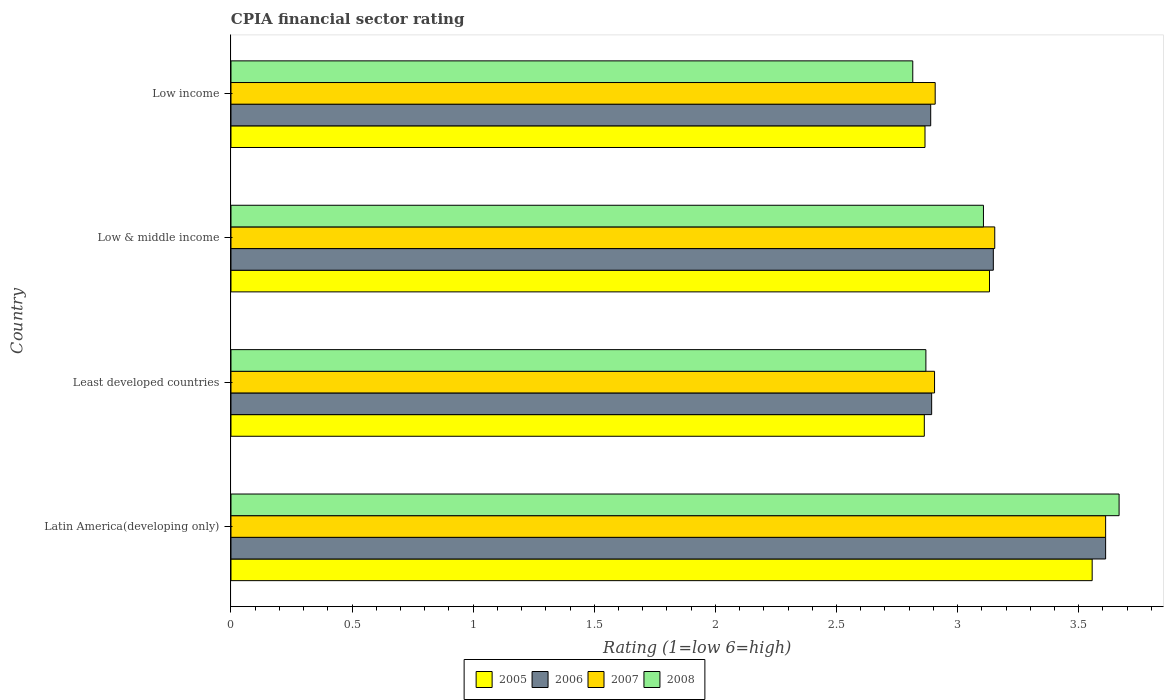How many different coloured bars are there?
Offer a terse response. 4. How many groups of bars are there?
Keep it short and to the point. 4. Are the number of bars on each tick of the Y-axis equal?
Provide a short and direct response. Yes. What is the label of the 1st group of bars from the top?
Your answer should be very brief. Low income. In how many cases, is the number of bars for a given country not equal to the number of legend labels?
Your answer should be compact. 0. What is the CPIA rating in 2008 in Low income?
Offer a very short reply. 2.81. Across all countries, what is the maximum CPIA rating in 2007?
Offer a terse response. 3.61. Across all countries, what is the minimum CPIA rating in 2006?
Make the answer very short. 2.89. In which country was the CPIA rating in 2007 maximum?
Your response must be concise. Latin America(developing only). In which country was the CPIA rating in 2005 minimum?
Provide a succinct answer. Least developed countries. What is the total CPIA rating in 2006 in the graph?
Provide a succinct answer. 12.54. What is the difference between the CPIA rating in 2008 in Least developed countries and that in Low income?
Give a very brief answer. 0.05. What is the difference between the CPIA rating in 2008 in Low income and the CPIA rating in 2007 in Low & middle income?
Your answer should be very brief. -0.34. What is the average CPIA rating in 2008 per country?
Provide a succinct answer. 3.11. What is the difference between the CPIA rating in 2005 and CPIA rating in 2008 in Low & middle income?
Give a very brief answer. 0.02. What is the ratio of the CPIA rating in 2008 in Least developed countries to that in Low income?
Provide a short and direct response. 1.02. Is the CPIA rating in 2008 in Latin America(developing only) less than that in Low income?
Keep it short and to the point. No. What is the difference between the highest and the second highest CPIA rating in 2008?
Ensure brevity in your answer.  0.56. What is the difference between the highest and the lowest CPIA rating in 2008?
Provide a short and direct response. 0.85. Is it the case that in every country, the sum of the CPIA rating in 2005 and CPIA rating in 2008 is greater than the sum of CPIA rating in 2006 and CPIA rating in 2007?
Offer a terse response. No. Is it the case that in every country, the sum of the CPIA rating in 2005 and CPIA rating in 2006 is greater than the CPIA rating in 2008?
Give a very brief answer. Yes. How many bars are there?
Your answer should be compact. 16. Are all the bars in the graph horizontal?
Keep it short and to the point. Yes. How many countries are there in the graph?
Your answer should be very brief. 4. What is the difference between two consecutive major ticks on the X-axis?
Offer a very short reply. 0.5. Are the values on the major ticks of X-axis written in scientific E-notation?
Give a very brief answer. No. How many legend labels are there?
Your response must be concise. 4. How are the legend labels stacked?
Your answer should be very brief. Horizontal. What is the title of the graph?
Offer a very short reply. CPIA financial sector rating. Does "1993" appear as one of the legend labels in the graph?
Provide a short and direct response. No. What is the Rating (1=low 6=high) of 2005 in Latin America(developing only)?
Offer a very short reply. 3.56. What is the Rating (1=low 6=high) in 2006 in Latin America(developing only)?
Your answer should be compact. 3.61. What is the Rating (1=low 6=high) of 2007 in Latin America(developing only)?
Provide a short and direct response. 3.61. What is the Rating (1=low 6=high) of 2008 in Latin America(developing only)?
Your answer should be very brief. 3.67. What is the Rating (1=low 6=high) of 2005 in Least developed countries?
Your answer should be compact. 2.86. What is the Rating (1=low 6=high) of 2006 in Least developed countries?
Offer a very short reply. 2.89. What is the Rating (1=low 6=high) of 2007 in Least developed countries?
Your answer should be compact. 2.9. What is the Rating (1=low 6=high) in 2008 in Least developed countries?
Offer a terse response. 2.87. What is the Rating (1=low 6=high) of 2005 in Low & middle income?
Your response must be concise. 3.13. What is the Rating (1=low 6=high) in 2006 in Low & middle income?
Give a very brief answer. 3.15. What is the Rating (1=low 6=high) of 2007 in Low & middle income?
Offer a terse response. 3.15. What is the Rating (1=low 6=high) of 2008 in Low & middle income?
Your response must be concise. 3.11. What is the Rating (1=low 6=high) of 2005 in Low income?
Offer a terse response. 2.87. What is the Rating (1=low 6=high) in 2006 in Low income?
Keep it short and to the point. 2.89. What is the Rating (1=low 6=high) of 2007 in Low income?
Make the answer very short. 2.91. What is the Rating (1=low 6=high) of 2008 in Low income?
Provide a short and direct response. 2.81. Across all countries, what is the maximum Rating (1=low 6=high) of 2005?
Your answer should be very brief. 3.56. Across all countries, what is the maximum Rating (1=low 6=high) of 2006?
Ensure brevity in your answer.  3.61. Across all countries, what is the maximum Rating (1=low 6=high) of 2007?
Ensure brevity in your answer.  3.61. Across all countries, what is the maximum Rating (1=low 6=high) of 2008?
Offer a terse response. 3.67. Across all countries, what is the minimum Rating (1=low 6=high) in 2005?
Make the answer very short. 2.86. Across all countries, what is the minimum Rating (1=low 6=high) in 2006?
Make the answer very short. 2.89. Across all countries, what is the minimum Rating (1=low 6=high) in 2007?
Give a very brief answer. 2.9. Across all countries, what is the minimum Rating (1=low 6=high) of 2008?
Provide a short and direct response. 2.81. What is the total Rating (1=low 6=high) of 2005 in the graph?
Keep it short and to the point. 12.41. What is the total Rating (1=low 6=high) in 2006 in the graph?
Offer a very short reply. 12.54. What is the total Rating (1=low 6=high) of 2007 in the graph?
Your answer should be very brief. 12.58. What is the total Rating (1=low 6=high) of 2008 in the graph?
Offer a terse response. 12.46. What is the difference between the Rating (1=low 6=high) of 2005 in Latin America(developing only) and that in Least developed countries?
Make the answer very short. 0.69. What is the difference between the Rating (1=low 6=high) in 2006 in Latin America(developing only) and that in Least developed countries?
Give a very brief answer. 0.72. What is the difference between the Rating (1=low 6=high) in 2007 in Latin America(developing only) and that in Least developed countries?
Ensure brevity in your answer.  0.71. What is the difference between the Rating (1=low 6=high) of 2008 in Latin America(developing only) and that in Least developed countries?
Provide a short and direct response. 0.8. What is the difference between the Rating (1=low 6=high) of 2005 in Latin America(developing only) and that in Low & middle income?
Make the answer very short. 0.42. What is the difference between the Rating (1=low 6=high) of 2006 in Latin America(developing only) and that in Low & middle income?
Offer a very short reply. 0.46. What is the difference between the Rating (1=low 6=high) of 2007 in Latin America(developing only) and that in Low & middle income?
Offer a terse response. 0.46. What is the difference between the Rating (1=low 6=high) of 2008 in Latin America(developing only) and that in Low & middle income?
Give a very brief answer. 0.56. What is the difference between the Rating (1=low 6=high) in 2005 in Latin America(developing only) and that in Low income?
Provide a short and direct response. 0.69. What is the difference between the Rating (1=low 6=high) in 2006 in Latin America(developing only) and that in Low income?
Keep it short and to the point. 0.72. What is the difference between the Rating (1=low 6=high) of 2007 in Latin America(developing only) and that in Low income?
Keep it short and to the point. 0.7. What is the difference between the Rating (1=low 6=high) of 2008 in Latin America(developing only) and that in Low income?
Your response must be concise. 0.85. What is the difference between the Rating (1=low 6=high) in 2005 in Least developed countries and that in Low & middle income?
Keep it short and to the point. -0.27. What is the difference between the Rating (1=low 6=high) of 2006 in Least developed countries and that in Low & middle income?
Your answer should be compact. -0.25. What is the difference between the Rating (1=low 6=high) of 2007 in Least developed countries and that in Low & middle income?
Your answer should be very brief. -0.25. What is the difference between the Rating (1=low 6=high) in 2008 in Least developed countries and that in Low & middle income?
Provide a succinct answer. -0.24. What is the difference between the Rating (1=low 6=high) of 2005 in Least developed countries and that in Low income?
Your answer should be compact. -0. What is the difference between the Rating (1=low 6=high) in 2006 in Least developed countries and that in Low income?
Your response must be concise. 0. What is the difference between the Rating (1=low 6=high) of 2007 in Least developed countries and that in Low income?
Provide a succinct answer. -0. What is the difference between the Rating (1=low 6=high) in 2008 in Least developed countries and that in Low income?
Keep it short and to the point. 0.05. What is the difference between the Rating (1=low 6=high) of 2005 in Low & middle income and that in Low income?
Make the answer very short. 0.27. What is the difference between the Rating (1=low 6=high) in 2006 in Low & middle income and that in Low income?
Make the answer very short. 0.26. What is the difference between the Rating (1=low 6=high) in 2007 in Low & middle income and that in Low income?
Ensure brevity in your answer.  0.25. What is the difference between the Rating (1=low 6=high) in 2008 in Low & middle income and that in Low income?
Offer a terse response. 0.29. What is the difference between the Rating (1=low 6=high) in 2005 in Latin America(developing only) and the Rating (1=low 6=high) in 2006 in Least developed countries?
Your answer should be very brief. 0.66. What is the difference between the Rating (1=low 6=high) of 2005 in Latin America(developing only) and the Rating (1=low 6=high) of 2007 in Least developed countries?
Your answer should be compact. 0.65. What is the difference between the Rating (1=low 6=high) of 2005 in Latin America(developing only) and the Rating (1=low 6=high) of 2008 in Least developed countries?
Provide a succinct answer. 0.69. What is the difference between the Rating (1=low 6=high) of 2006 in Latin America(developing only) and the Rating (1=low 6=high) of 2007 in Least developed countries?
Ensure brevity in your answer.  0.71. What is the difference between the Rating (1=low 6=high) of 2006 in Latin America(developing only) and the Rating (1=low 6=high) of 2008 in Least developed countries?
Ensure brevity in your answer.  0.74. What is the difference between the Rating (1=low 6=high) in 2007 in Latin America(developing only) and the Rating (1=low 6=high) in 2008 in Least developed countries?
Provide a short and direct response. 0.74. What is the difference between the Rating (1=low 6=high) in 2005 in Latin America(developing only) and the Rating (1=low 6=high) in 2006 in Low & middle income?
Offer a very short reply. 0.41. What is the difference between the Rating (1=low 6=high) of 2005 in Latin America(developing only) and the Rating (1=low 6=high) of 2007 in Low & middle income?
Offer a terse response. 0.4. What is the difference between the Rating (1=low 6=high) in 2005 in Latin America(developing only) and the Rating (1=low 6=high) in 2008 in Low & middle income?
Your answer should be very brief. 0.45. What is the difference between the Rating (1=low 6=high) of 2006 in Latin America(developing only) and the Rating (1=low 6=high) of 2007 in Low & middle income?
Your answer should be very brief. 0.46. What is the difference between the Rating (1=low 6=high) in 2006 in Latin America(developing only) and the Rating (1=low 6=high) in 2008 in Low & middle income?
Give a very brief answer. 0.5. What is the difference between the Rating (1=low 6=high) in 2007 in Latin America(developing only) and the Rating (1=low 6=high) in 2008 in Low & middle income?
Provide a succinct answer. 0.5. What is the difference between the Rating (1=low 6=high) of 2005 in Latin America(developing only) and the Rating (1=low 6=high) of 2007 in Low income?
Your answer should be compact. 0.65. What is the difference between the Rating (1=low 6=high) of 2005 in Latin America(developing only) and the Rating (1=low 6=high) of 2008 in Low income?
Offer a terse response. 0.74. What is the difference between the Rating (1=low 6=high) in 2006 in Latin America(developing only) and the Rating (1=low 6=high) in 2007 in Low income?
Make the answer very short. 0.7. What is the difference between the Rating (1=low 6=high) in 2006 in Latin America(developing only) and the Rating (1=low 6=high) in 2008 in Low income?
Offer a very short reply. 0.8. What is the difference between the Rating (1=low 6=high) in 2007 in Latin America(developing only) and the Rating (1=low 6=high) in 2008 in Low income?
Your answer should be very brief. 0.8. What is the difference between the Rating (1=low 6=high) in 2005 in Least developed countries and the Rating (1=low 6=high) in 2006 in Low & middle income?
Ensure brevity in your answer.  -0.28. What is the difference between the Rating (1=low 6=high) of 2005 in Least developed countries and the Rating (1=low 6=high) of 2007 in Low & middle income?
Provide a short and direct response. -0.29. What is the difference between the Rating (1=low 6=high) of 2005 in Least developed countries and the Rating (1=low 6=high) of 2008 in Low & middle income?
Provide a succinct answer. -0.24. What is the difference between the Rating (1=low 6=high) in 2006 in Least developed countries and the Rating (1=low 6=high) in 2007 in Low & middle income?
Keep it short and to the point. -0.26. What is the difference between the Rating (1=low 6=high) in 2006 in Least developed countries and the Rating (1=low 6=high) in 2008 in Low & middle income?
Keep it short and to the point. -0.21. What is the difference between the Rating (1=low 6=high) in 2007 in Least developed countries and the Rating (1=low 6=high) in 2008 in Low & middle income?
Offer a very short reply. -0.2. What is the difference between the Rating (1=low 6=high) of 2005 in Least developed countries and the Rating (1=low 6=high) of 2006 in Low income?
Offer a terse response. -0.03. What is the difference between the Rating (1=low 6=high) in 2005 in Least developed countries and the Rating (1=low 6=high) in 2007 in Low income?
Your response must be concise. -0.04. What is the difference between the Rating (1=low 6=high) in 2005 in Least developed countries and the Rating (1=low 6=high) in 2008 in Low income?
Your answer should be very brief. 0.05. What is the difference between the Rating (1=low 6=high) in 2006 in Least developed countries and the Rating (1=low 6=high) in 2007 in Low income?
Provide a short and direct response. -0.01. What is the difference between the Rating (1=low 6=high) of 2006 in Least developed countries and the Rating (1=low 6=high) of 2008 in Low income?
Give a very brief answer. 0.08. What is the difference between the Rating (1=low 6=high) of 2007 in Least developed countries and the Rating (1=low 6=high) of 2008 in Low income?
Make the answer very short. 0.09. What is the difference between the Rating (1=low 6=high) of 2005 in Low & middle income and the Rating (1=low 6=high) of 2006 in Low income?
Ensure brevity in your answer.  0.24. What is the difference between the Rating (1=low 6=high) in 2005 in Low & middle income and the Rating (1=low 6=high) in 2007 in Low income?
Give a very brief answer. 0.22. What is the difference between the Rating (1=low 6=high) in 2005 in Low & middle income and the Rating (1=low 6=high) in 2008 in Low income?
Your answer should be compact. 0.32. What is the difference between the Rating (1=low 6=high) of 2006 in Low & middle income and the Rating (1=low 6=high) of 2007 in Low income?
Make the answer very short. 0.24. What is the difference between the Rating (1=low 6=high) of 2006 in Low & middle income and the Rating (1=low 6=high) of 2008 in Low income?
Ensure brevity in your answer.  0.33. What is the difference between the Rating (1=low 6=high) in 2007 in Low & middle income and the Rating (1=low 6=high) in 2008 in Low income?
Keep it short and to the point. 0.34. What is the average Rating (1=low 6=high) of 2005 per country?
Your response must be concise. 3.1. What is the average Rating (1=low 6=high) of 2006 per country?
Your response must be concise. 3.14. What is the average Rating (1=low 6=high) in 2007 per country?
Your answer should be very brief. 3.14. What is the average Rating (1=low 6=high) of 2008 per country?
Your response must be concise. 3.11. What is the difference between the Rating (1=low 6=high) in 2005 and Rating (1=low 6=high) in 2006 in Latin America(developing only)?
Your answer should be very brief. -0.06. What is the difference between the Rating (1=low 6=high) of 2005 and Rating (1=low 6=high) of 2007 in Latin America(developing only)?
Keep it short and to the point. -0.06. What is the difference between the Rating (1=low 6=high) of 2005 and Rating (1=low 6=high) of 2008 in Latin America(developing only)?
Make the answer very short. -0.11. What is the difference between the Rating (1=low 6=high) of 2006 and Rating (1=low 6=high) of 2008 in Latin America(developing only)?
Your answer should be compact. -0.06. What is the difference between the Rating (1=low 6=high) in 2007 and Rating (1=low 6=high) in 2008 in Latin America(developing only)?
Your response must be concise. -0.06. What is the difference between the Rating (1=low 6=high) in 2005 and Rating (1=low 6=high) in 2006 in Least developed countries?
Your response must be concise. -0.03. What is the difference between the Rating (1=low 6=high) in 2005 and Rating (1=low 6=high) in 2007 in Least developed countries?
Provide a succinct answer. -0.04. What is the difference between the Rating (1=low 6=high) in 2005 and Rating (1=low 6=high) in 2008 in Least developed countries?
Provide a succinct answer. -0.01. What is the difference between the Rating (1=low 6=high) of 2006 and Rating (1=low 6=high) of 2007 in Least developed countries?
Your response must be concise. -0.01. What is the difference between the Rating (1=low 6=high) in 2006 and Rating (1=low 6=high) in 2008 in Least developed countries?
Offer a terse response. 0.02. What is the difference between the Rating (1=low 6=high) of 2007 and Rating (1=low 6=high) of 2008 in Least developed countries?
Provide a short and direct response. 0.04. What is the difference between the Rating (1=low 6=high) in 2005 and Rating (1=low 6=high) in 2006 in Low & middle income?
Provide a succinct answer. -0.02. What is the difference between the Rating (1=low 6=high) in 2005 and Rating (1=low 6=high) in 2007 in Low & middle income?
Offer a very short reply. -0.02. What is the difference between the Rating (1=low 6=high) in 2005 and Rating (1=low 6=high) in 2008 in Low & middle income?
Keep it short and to the point. 0.02. What is the difference between the Rating (1=low 6=high) of 2006 and Rating (1=low 6=high) of 2007 in Low & middle income?
Offer a very short reply. -0.01. What is the difference between the Rating (1=low 6=high) in 2006 and Rating (1=low 6=high) in 2008 in Low & middle income?
Give a very brief answer. 0.04. What is the difference between the Rating (1=low 6=high) in 2007 and Rating (1=low 6=high) in 2008 in Low & middle income?
Ensure brevity in your answer.  0.05. What is the difference between the Rating (1=low 6=high) in 2005 and Rating (1=low 6=high) in 2006 in Low income?
Give a very brief answer. -0.02. What is the difference between the Rating (1=low 6=high) of 2005 and Rating (1=low 6=high) of 2007 in Low income?
Provide a short and direct response. -0.04. What is the difference between the Rating (1=low 6=high) of 2005 and Rating (1=low 6=high) of 2008 in Low income?
Offer a terse response. 0.05. What is the difference between the Rating (1=low 6=high) of 2006 and Rating (1=low 6=high) of 2007 in Low income?
Your answer should be compact. -0.02. What is the difference between the Rating (1=low 6=high) in 2006 and Rating (1=low 6=high) in 2008 in Low income?
Your answer should be very brief. 0.07. What is the difference between the Rating (1=low 6=high) of 2007 and Rating (1=low 6=high) of 2008 in Low income?
Your answer should be compact. 0.09. What is the ratio of the Rating (1=low 6=high) in 2005 in Latin America(developing only) to that in Least developed countries?
Ensure brevity in your answer.  1.24. What is the ratio of the Rating (1=low 6=high) in 2006 in Latin America(developing only) to that in Least developed countries?
Your answer should be compact. 1.25. What is the ratio of the Rating (1=low 6=high) in 2007 in Latin America(developing only) to that in Least developed countries?
Ensure brevity in your answer.  1.24. What is the ratio of the Rating (1=low 6=high) in 2008 in Latin America(developing only) to that in Least developed countries?
Your answer should be compact. 1.28. What is the ratio of the Rating (1=low 6=high) of 2005 in Latin America(developing only) to that in Low & middle income?
Provide a succinct answer. 1.14. What is the ratio of the Rating (1=low 6=high) of 2006 in Latin America(developing only) to that in Low & middle income?
Your response must be concise. 1.15. What is the ratio of the Rating (1=low 6=high) of 2007 in Latin America(developing only) to that in Low & middle income?
Provide a succinct answer. 1.15. What is the ratio of the Rating (1=low 6=high) of 2008 in Latin America(developing only) to that in Low & middle income?
Your answer should be very brief. 1.18. What is the ratio of the Rating (1=low 6=high) in 2005 in Latin America(developing only) to that in Low income?
Give a very brief answer. 1.24. What is the ratio of the Rating (1=low 6=high) in 2006 in Latin America(developing only) to that in Low income?
Make the answer very short. 1.25. What is the ratio of the Rating (1=low 6=high) in 2007 in Latin America(developing only) to that in Low income?
Your response must be concise. 1.24. What is the ratio of the Rating (1=low 6=high) of 2008 in Latin America(developing only) to that in Low income?
Keep it short and to the point. 1.3. What is the ratio of the Rating (1=low 6=high) of 2005 in Least developed countries to that in Low & middle income?
Your answer should be compact. 0.91. What is the ratio of the Rating (1=low 6=high) of 2006 in Least developed countries to that in Low & middle income?
Your answer should be very brief. 0.92. What is the ratio of the Rating (1=low 6=high) in 2007 in Least developed countries to that in Low & middle income?
Make the answer very short. 0.92. What is the ratio of the Rating (1=low 6=high) in 2008 in Least developed countries to that in Low & middle income?
Your response must be concise. 0.92. What is the ratio of the Rating (1=low 6=high) in 2005 in Least developed countries to that in Low income?
Your answer should be compact. 1. What is the ratio of the Rating (1=low 6=high) of 2006 in Least developed countries to that in Low income?
Offer a very short reply. 1. What is the ratio of the Rating (1=low 6=high) in 2008 in Least developed countries to that in Low income?
Offer a terse response. 1.02. What is the ratio of the Rating (1=low 6=high) in 2005 in Low & middle income to that in Low income?
Your answer should be compact. 1.09. What is the ratio of the Rating (1=low 6=high) in 2006 in Low & middle income to that in Low income?
Your answer should be compact. 1.09. What is the ratio of the Rating (1=low 6=high) in 2007 in Low & middle income to that in Low income?
Provide a succinct answer. 1.08. What is the ratio of the Rating (1=low 6=high) in 2008 in Low & middle income to that in Low income?
Offer a terse response. 1.1. What is the difference between the highest and the second highest Rating (1=low 6=high) of 2005?
Provide a succinct answer. 0.42. What is the difference between the highest and the second highest Rating (1=low 6=high) in 2006?
Give a very brief answer. 0.46. What is the difference between the highest and the second highest Rating (1=low 6=high) in 2007?
Offer a very short reply. 0.46. What is the difference between the highest and the second highest Rating (1=low 6=high) of 2008?
Provide a short and direct response. 0.56. What is the difference between the highest and the lowest Rating (1=low 6=high) of 2005?
Offer a terse response. 0.69. What is the difference between the highest and the lowest Rating (1=low 6=high) of 2006?
Offer a very short reply. 0.72. What is the difference between the highest and the lowest Rating (1=low 6=high) of 2007?
Ensure brevity in your answer.  0.71. What is the difference between the highest and the lowest Rating (1=low 6=high) in 2008?
Offer a very short reply. 0.85. 